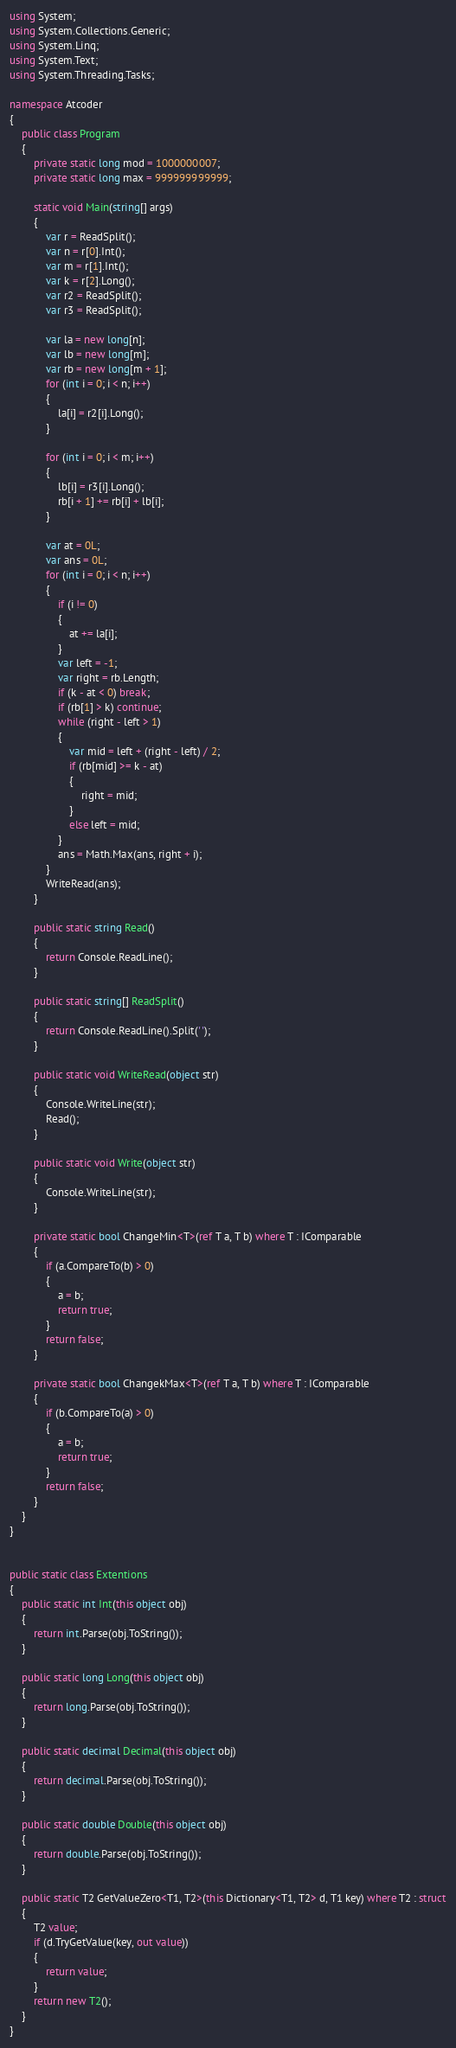<code> <loc_0><loc_0><loc_500><loc_500><_C#_>using System;
using System.Collections.Generic;
using System.Linq;
using System.Text;
using System.Threading.Tasks;

namespace Atcoder
{
    public class Program
    {
        private static long mod = 1000000007;
        private static long max = 999999999999;

        static void Main(string[] args)
        {
            var r = ReadSplit();
            var n = r[0].Int();
            var m = r[1].Int();
            var k = r[2].Long();
            var r2 = ReadSplit();
            var r3 = ReadSplit();

            var la = new long[n];
            var lb = new long[m];
            var rb = new long[m + 1];
            for (int i = 0; i < n; i++)
            {
                la[i] = r2[i].Long();
            }

            for (int i = 0; i < m; i++)
            {
                lb[i] = r3[i].Long();
                rb[i + 1] += rb[i] + lb[i];
            }

            var at = 0L;
            var ans = 0L;
            for (int i = 0; i < n; i++)
            {
                if (i != 0)
                {
                    at += la[i];
                }
                var left = -1;
                var right = rb.Length;
                if (k - at < 0) break;
                if (rb[1] > k) continue;
                while (right - left > 1)
                {
                    var mid = left + (right - left) / 2;
                    if (rb[mid] >= k - at)
                    {
                        right = mid;
                    }
                    else left = mid;
                }
                ans = Math.Max(ans, right + i);
            }
            WriteRead(ans);
        }

        public static string Read()
        {
            return Console.ReadLine();
        }

        public static string[] ReadSplit()
        {
            return Console.ReadLine().Split(' ');
        }

        public static void WriteRead(object str)
        {
            Console.WriteLine(str);
            Read();
        }

        public static void Write(object str)
        {
            Console.WriteLine(str);
        }

        private static bool ChangeMin<T>(ref T a, T b) where T : IComparable
        {
            if (a.CompareTo(b) > 0)
            {
                a = b;
                return true;
            }
            return false;
        }

        private static bool ChangekMax<T>(ref T a, T b) where T : IComparable
        {
            if (b.CompareTo(a) > 0)
            {
                a = b;
                return true;
            }
            return false;
        }
    }
}


public static class Extentions
{
    public static int Int(this object obj)
    {
        return int.Parse(obj.ToString());
    }

    public static long Long(this object obj)
    {
        return long.Parse(obj.ToString());
    }

    public static decimal Decimal(this object obj)
    {
        return decimal.Parse(obj.ToString());
    }

    public static double Double(this object obj)
    {
        return double.Parse(obj.ToString());
    }

    public static T2 GetValueZero<T1, T2>(this Dictionary<T1, T2> d, T1 key) where T2 : struct
    {
        T2 value;
        if (d.TryGetValue(key, out value))
        {
            return value;
        }
        return new T2();
    }
}

</code> 